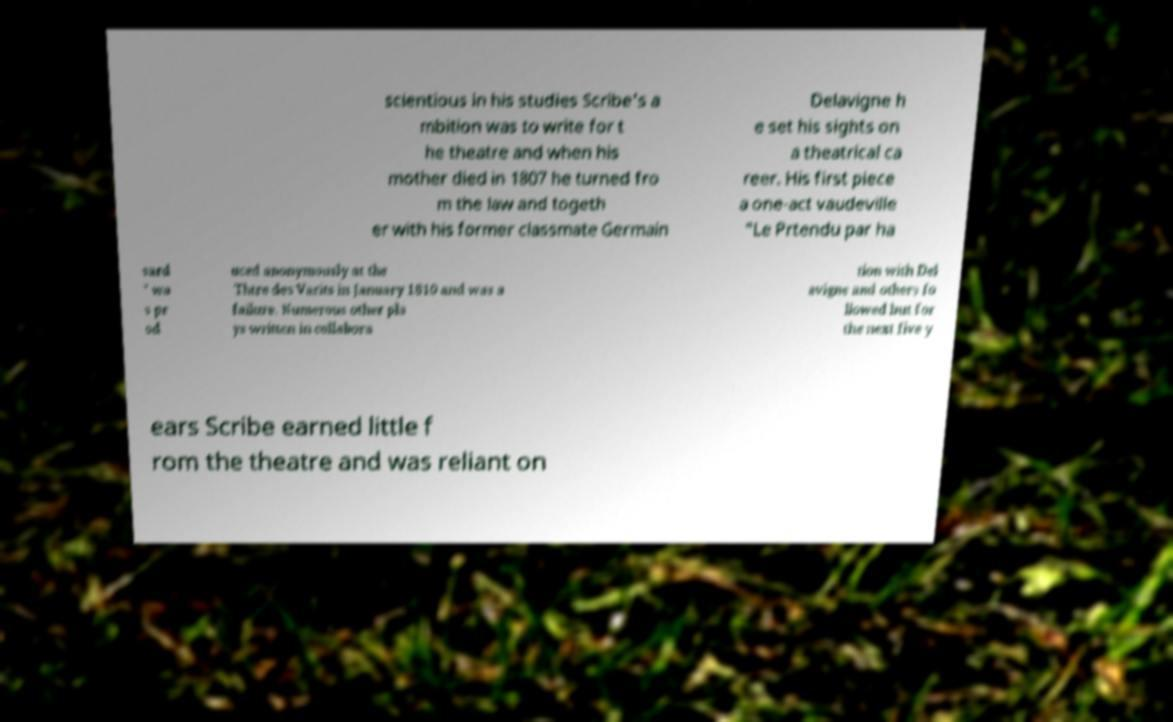What messages or text are displayed in this image? I need them in a readable, typed format. scientious in his studies Scribe's a mbition was to write for t he theatre and when his mother died in 1807 he turned fro m the law and togeth er with his former classmate Germain Delavigne h e set his sights on a theatrical ca reer. His first piece a one-act vaudeville "Le Prtendu par ha sard " wa s pr od uced anonymously at the Thtre des Varits in January 1810 and was a failure. Numerous other pla ys written in collabora tion with Del avigne and others fo llowed but for the next five y ears Scribe earned little f rom the theatre and was reliant on 